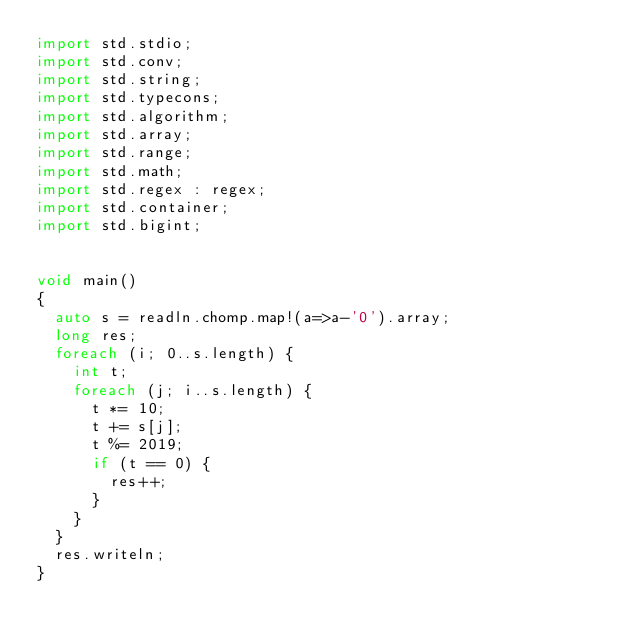<code> <loc_0><loc_0><loc_500><loc_500><_D_>import std.stdio;
import std.conv;
import std.string;
import std.typecons;
import std.algorithm;
import std.array;
import std.range;
import std.math;
import std.regex : regex;
import std.container;
import std.bigint;


void main()
{
  auto s = readln.chomp.map!(a=>a-'0').array;
  long res;
  foreach (i; 0..s.length) {
    int t;
    foreach (j; i..s.length) {
      t *= 10;
      t += s[j];
      t %= 2019;
      if (t == 0) {
        res++;
      }
    }
  }
  res.writeln;
}
</code> 